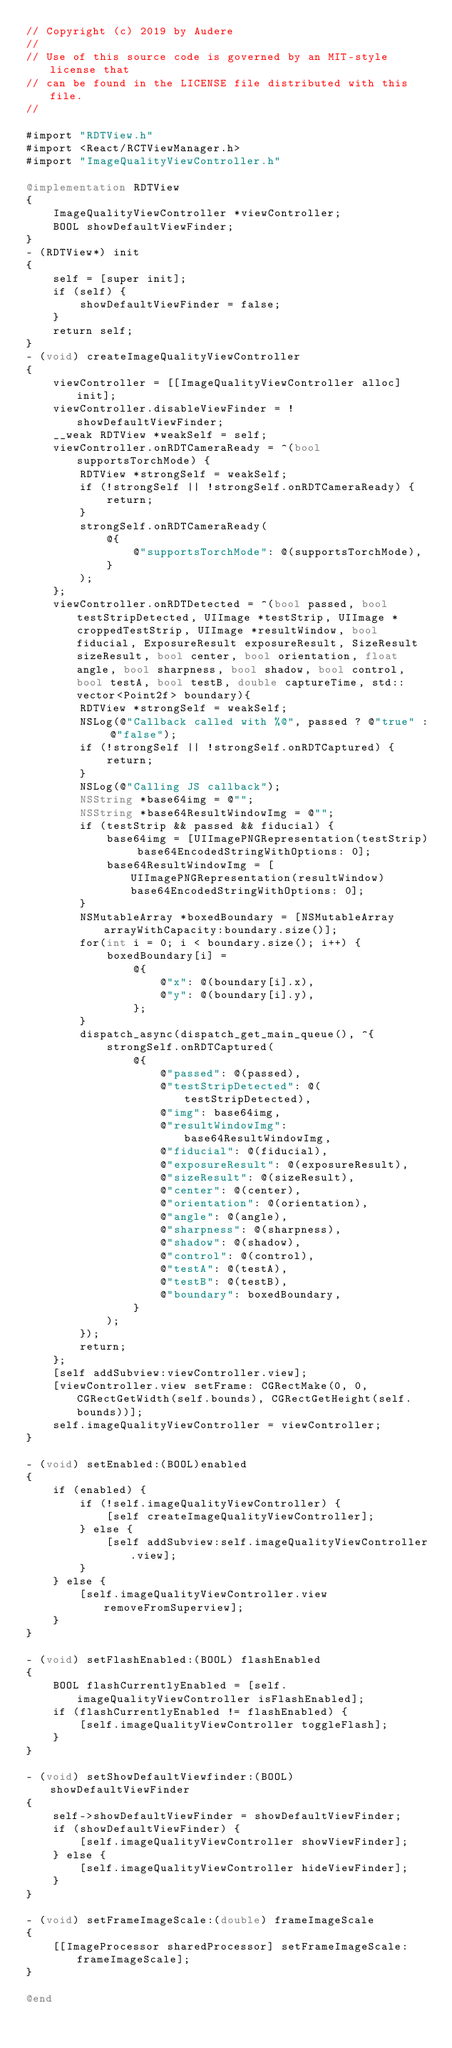Convert code to text. <code><loc_0><loc_0><loc_500><loc_500><_ObjectiveC_>// Copyright (c) 2019 by Audere
//
// Use of this source code is governed by an MIT-style license that
// can be found in the LICENSE file distributed with this file.
//

#import "RDTView.h"
#import <React/RCTViewManager.h>
#import "ImageQualityViewController.h"

@implementation RDTView
{
    ImageQualityViewController *viewController;
    BOOL showDefaultViewFinder;
}
- (RDTView*) init
{
    self = [super init];
    if (self) {
        showDefaultViewFinder = false;
    }
    return self;
}
- (void) createImageQualityViewController
{
    viewController = [[ImageQualityViewController alloc] init];
    viewController.disableViewFinder = !showDefaultViewFinder;
    __weak RDTView *weakSelf = self;
    viewController.onRDTCameraReady = ^(bool supportsTorchMode) {
        RDTView *strongSelf = weakSelf;
        if (!strongSelf || !strongSelf.onRDTCameraReady) {
            return;
        }
        strongSelf.onRDTCameraReady(
            @{
                @"supportsTorchMode": @(supportsTorchMode),
            }
        );
    };
    viewController.onRDTDetected = ^(bool passed, bool testStripDetected, UIImage *testStrip, UIImage *croppedTestStrip, UIImage *resultWindow, bool fiducial, ExposureResult exposureResult, SizeResult sizeResult, bool center, bool orientation, float angle, bool sharpness, bool shadow, bool control, bool testA, bool testB, double captureTime, std::vector<Point2f> boundary){
        RDTView *strongSelf = weakSelf;
        NSLog(@"Callback called with %@", passed ? @"true" : @"false");
        if (!strongSelf || !strongSelf.onRDTCaptured) {
            return;
        }
        NSLog(@"Calling JS callback");
        NSString *base64img = @"";
        NSString *base64ResultWindowImg = @"";
        if (testStrip && passed && fiducial) {
            base64img = [UIImagePNGRepresentation(testStrip) base64EncodedStringWithOptions: 0];
            base64ResultWindowImg = [UIImagePNGRepresentation(resultWindow) base64EncodedStringWithOptions: 0];
        }
        NSMutableArray *boxedBoundary = [NSMutableArray arrayWithCapacity:boundary.size()];
        for(int i = 0; i < boundary.size(); i++) {
            boxedBoundary[i] =
                @{
                    @"x": @(boundary[i].x),
                    @"y": @(boundary[i].y),
                };
        }
        dispatch_async(dispatch_get_main_queue(), ^{
            strongSelf.onRDTCaptured(
                @{
                    @"passed": @(passed),
                    @"testStripDetected": @(testStripDetected),
                    @"img": base64img,
                    @"resultWindowImg": base64ResultWindowImg,
                    @"fiducial": @(fiducial),
                    @"exposureResult": @(exposureResult),
                    @"sizeResult": @(sizeResult),
                    @"center": @(center),
                    @"orientation": @(orientation),
                    @"angle": @(angle),
                    @"sharpness": @(sharpness),
                    @"shadow": @(shadow),
                    @"control": @(control),
                    @"testA": @(testA),
                    @"testB": @(testB),
                    @"boundary": boxedBoundary,
                }
            );
        });
        return;
    };
    [self addSubview:viewController.view];
    [viewController.view setFrame: CGRectMake(0, 0, CGRectGetWidth(self.bounds), CGRectGetHeight(self.bounds))];
    self.imageQualityViewController = viewController;
}

- (void) setEnabled:(BOOL)enabled
{
    if (enabled) {
        if (!self.imageQualityViewController) {
            [self createImageQualityViewController];
        } else {
            [self addSubview:self.imageQualityViewController.view];
        }
    } else {
        [self.imageQualityViewController.view removeFromSuperview];
    }
}

- (void) setFlashEnabled:(BOOL) flashEnabled
{
    BOOL flashCurrentlyEnabled = [self.imageQualityViewController isFlashEnabled];
    if (flashCurrentlyEnabled != flashEnabled) {
        [self.imageQualityViewController toggleFlash];
    }
}

- (void) setShowDefaultViewfinder:(BOOL) showDefaultViewFinder
{
    self->showDefaultViewFinder = showDefaultViewFinder;
    if (showDefaultViewFinder) {
        [self.imageQualityViewController showViewFinder];
    } else {
        [self.imageQualityViewController hideViewFinder];
    }
}

- (void) setFrameImageScale:(double) frameImageScale
{
    [[ImageProcessor sharedProcessor] setFrameImageScale: frameImageScale];
}

@end
</code> 